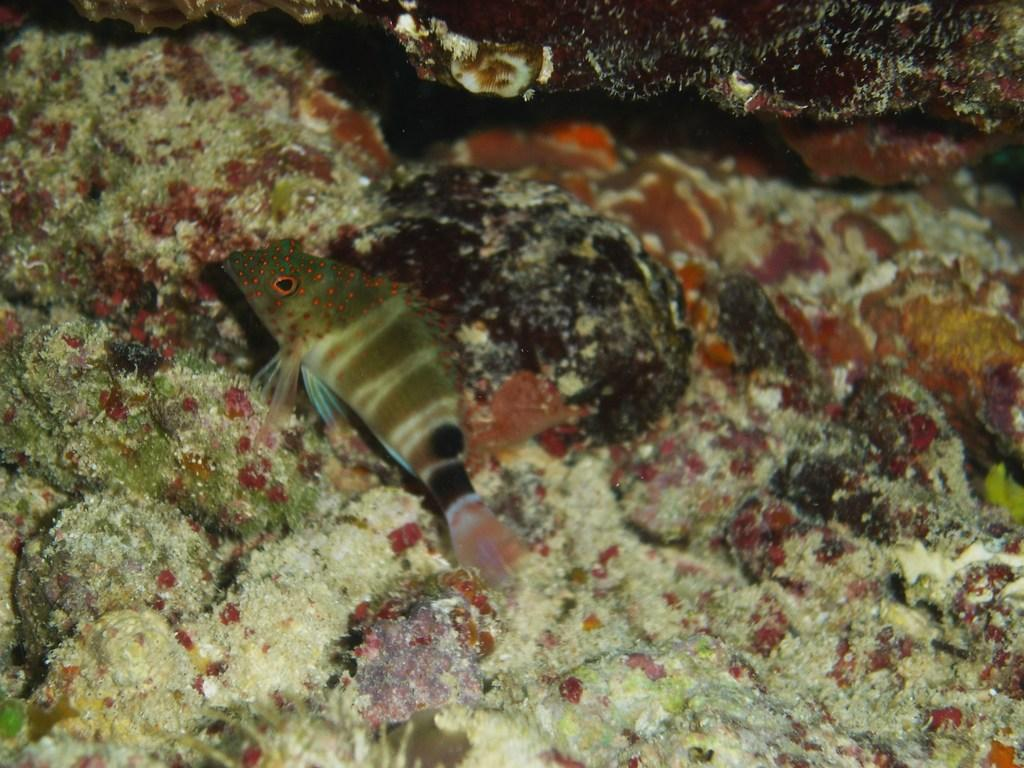What is the main feature of the image? There is a water body in the image. What type of animal can be seen in the water body? There is a fish in the water body. What other objects are present in the image? There are rocks in the image. Where is the seat located in the image? There is no seat present in the image. Can you tell me how many times the fish coughs in the image? Fish do not have the ability to cough, and there is no indication of coughing in the image. What type of beverage is being served in the image? There is no beverage present in the image; it features a water body with a fish and rocks. 